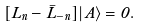<formula> <loc_0><loc_0><loc_500><loc_500>[ L _ { n } - \bar { L } _ { - n } ] | A \rangle = 0 .</formula> 